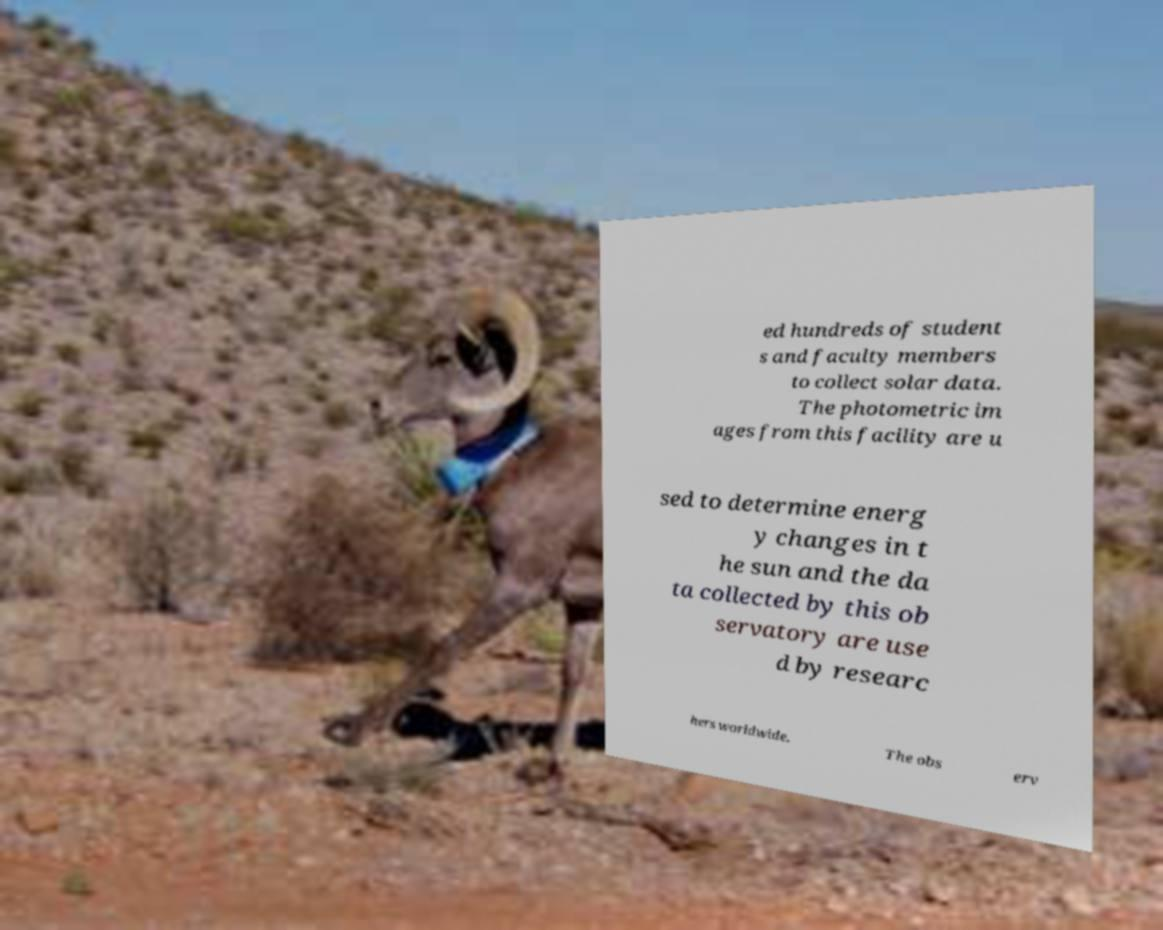Please identify and transcribe the text found in this image. ed hundreds of student s and faculty members to collect solar data. The photometric im ages from this facility are u sed to determine energ y changes in t he sun and the da ta collected by this ob servatory are use d by researc hers worldwide. The obs erv 